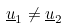<formula> <loc_0><loc_0><loc_500><loc_500>\underline { u } _ { 1 } \ne \underline { u } _ { 2 }</formula> 